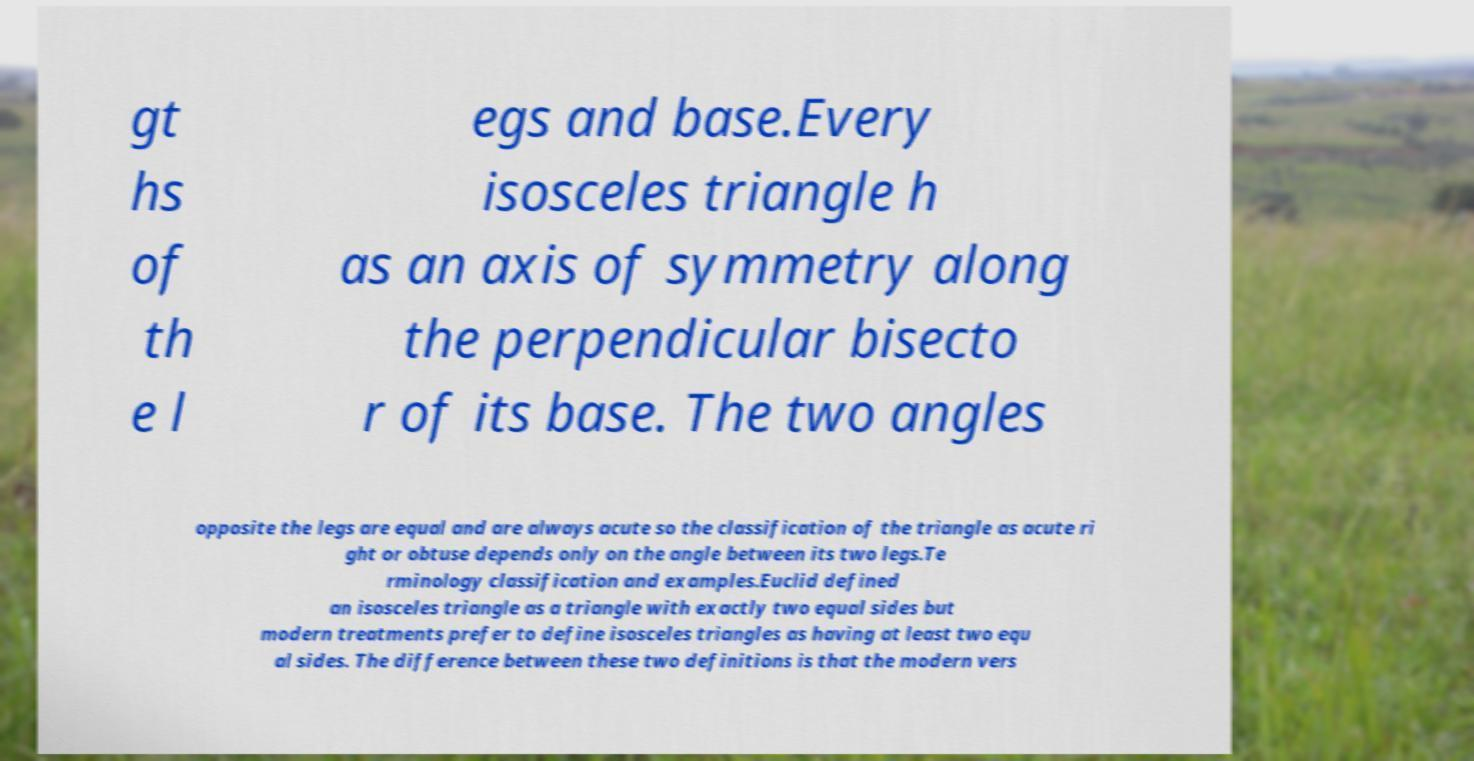Please identify and transcribe the text found in this image. gt hs of th e l egs and base.Every isosceles triangle h as an axis of symmetry along the perpendicular bisecto r of its base. The two angles opposite the legs are equal and are always acute so the classification of the triangle as acute ri ght or obtuse depends only on the angle between its two legs.Te rminology classification and examples.Euclid defined an isosceles triangle as a triangle with exactly two equal sides but modern treatments prefer to define isosceles triangles as having at least two equ al sides. The difference between these two definitions is that the modern vers 